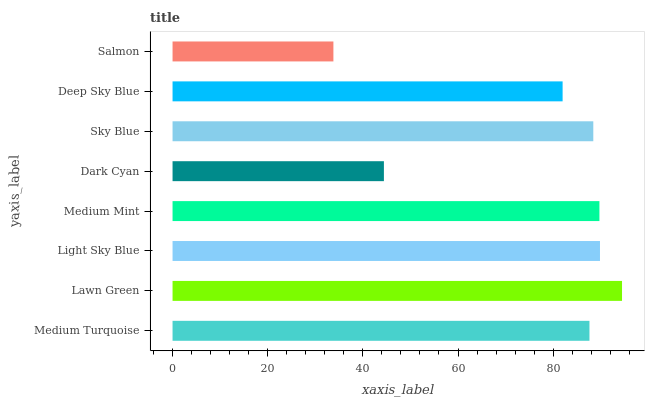Is Salmon the minimum?
Answer yes or no. Yes. Is Lawn Green the maximum?
Answer yes or no. Yes. Is Light Sky Blue the minimum?
Answer yes or no. No. Is Light Sky Blue the maximum?
Answer yes or no. No. Is Lawn Green greater than Light Sky Blue?
Answer yes or no. Yes. Is Light Sky Blue less than Lawn Green?
Answer yes or no. Yes. Is Light Sky Blue greater than Lawn Green?
Answer yes or no. No. Is Lawn Green less than Light Sky Blue?
Answer yes or no. No. Is Sky Blue the high median?
Answer yes or no. Yes. Is Medium Turquoise the low median?
Answer yes or no. Yes. Is Medium Mint the high median?
Answer yes or no. No. Is Salmon the low median?
Answer yes or no. No. 